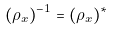<formula> <loc_0><loc_0><loc_500><loc_500>( \rho _ { x } ) ^ { - 1 } = ( \rho _ { x } ) ^ { * }</formula> 